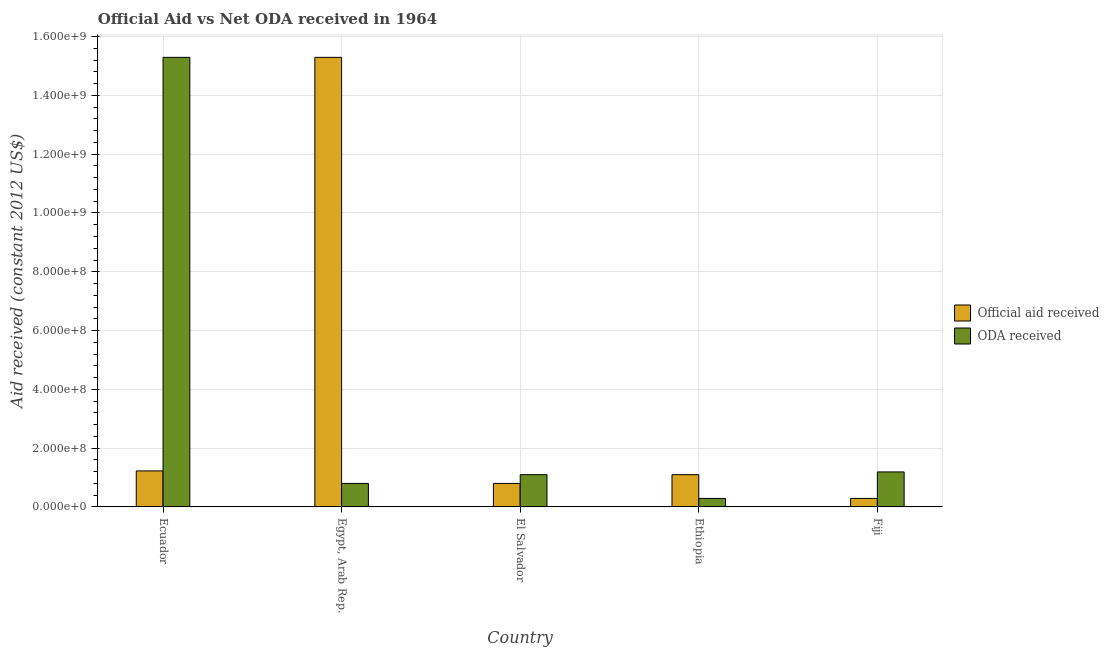How many different coloured bars are there?
Offer a terse response. 2. How many groups of bars are there?
Provide a short and direct response. 5. Are the number of bars per tick equal to the number of legend labels?
Your response must be concise. Yes. How many bars are there on the 5th tick from the right?
Provide a succinct answer. 2. What is the label of the 1st group of bars from the left?
Give a very brief answer. Ecuador. In how many cases, is the number of bars for a given country not equal to the number of legend labels?
Provide a succinct answer. 0. What is the oda received in Ethiopia?
Offer a very short reply. 2.89e+07. Across all countries, what is the maximum official aid received?
Your response must be concise. 1.53e+09. Across all countries, what is the minimum official aid received?
Provide a short and direct response. 2.89e+07. In which country was the oda received maximum?
Your answer should be very brief. Ecuador. In which country was the official aid received minimum?
Your response must be concise. Fiji. What is the total official aid received in the graph?
Provide a succinct answer. 1.87e+09. What is the difference between the official aid received in Ecuador and that in Egypt, Arab Rep.?
Offer a very short reply. -1.41e+09. What is the difference between the oda received in Ecuador and the official aid received in Ethiopia?
Your response must be concise. 1.42e+09. What is the average oda received per country?
Your response must be concise. 3.73e+08. What is the difference between the official aid received and oda received in El Salvador?
Give a very brief answer. -2.98e+07. What is the ratio of the official aid received in Egypt, Arab Rep. to that in Ethiopia?
Make the answer very short. 13.94. What is the difference between the highest and the second highest official aid received?
Make the answer very short. 1.41e+09. What is the difference between the highest and the lowest official aid received?
Your response must be concise. 1.50e+09. Is the sum of the official aid received in Ecuador and Ethiopia greater than the maximum oda received across all countries?
Provide a succinct answer. No. What does the 2nd bar from the left in Fiji represents?
Provide a succinct answer. ODA received. What does the 1st bar from the right in Ethiopia represents?
Your response must be concise. ODA received. How many bars are there?
Ensure brevity in your answer.  10. How many countries are there in the graph?
Keep it short and to the point. 5. What is the difference between two consecutive major ticks on the Y-axis?
Keep it short and to the point. 2.00e+08. Are the values on the major ticks of Y-axis written in scientific E-notation?
Keep it short and to the point. Yes. Where does the legend appear in the graph?
Offer a very short reply. Center right. How are the legend labels stacked?
Give a very brief answer. Vertical. What is the title of the graph?
Ensure brevity in your answer.  Official Aid vs Net ODA received in 1964 . Does "Excluding technical cooperation" appear as one of the legend labels in the graph?
Your response must be concise. No. What is the label or title of the Y-axis?
Offer a very short reply. Aid received (constant 2012 US$). What is the Aid received (constant 2012 US$) of Official aid received in Ecuador?
Make the answer very short. 1.23e+08. What is the Aid received (constant 2012 US$) in ODA received in Ecuador?
Give a very brief answer. 1.53e+09. What is the Aid received (constant 2012 US$) in Official aid received in Egypt, Arab Rep.?
Your answer should be compact. 1.53e+09. What is the Aid received (constant 2012 US$) in ODA received in Egypt, Arab Rep.?
Ensure brevity in your answer.  8.00e+07. What is the Aid received (constant 2012 US$) in Official aid received in El Salvador?
Your response must be concise. 8.00e+07. What is the Aid received (constant 2012 US$) of ODA received in El Salvador?
Ensure brevity in your answer.  1.10e+08. What is the Aid received (constant 2012 US$) in Official aid received in Ethiopia?
Offer a very short reply. 1.10e+08. What is the Aid received (constant 2012 US$) in ODA received in Ethiopia?
Your response must be concise. 2.89e+07. What is the Aid received (constant 2012 US$) in Official aid received in Fiji?
Give a very brief answer. 2.89e+07. What is the Aid received (constant 2012 US$) of ODA received in Fiji?
Your response must be concise. 1.19e+08. Across all countries, what is the maximum Aid received (constant 2012 US$) in Official aid received?
Your answer should be compact. 1.53e+09. Across all countries, what is the maximum Aid received (constant 2012 US$) in ODA received?
Provide a short and direct response. 1.53e+09. Across all countries, what is the minimum Aid received (constant 2012 US$) of Official aid received?
Offer a terse response. 2.89e+07. Across all countries, what is the minimum Aid received (constant 2012 US$) in ODA received?
Your response must be concise. 2.89e+07. What is the total Aid received (constant 2012 US$) in Official aid received in the graph?
Ensure brevity in your answer.  1.87e+09. What is the total Aid received (constant 2012 US$) in ODA received in the graph?
Make the answer very short. 1.87e+09. What is the difference between the Aid received (constant 2012 US$) of Official aid received in Ecuador and that in Egypt, Arab Rep.?
Keep it short and to the point. -1.41e+09. What is the difference between the Aid received (constant 2012 US$) in ODA received in Ecuador and that in Egypt, Arab Rep.?
Make the answer very short. 1.45e+09. What is the difference between the Aid received (constant 2012 US$) in Official aid received in Ecuador and that in El Salvador?
Keep it short and to the point. 4.26e+07. What is the difference between the Aid received (constant 2012 US$) in ODA received in Ecuador and that in El Salvador?
Offer a very short reply. 1.42e+09. What is the difference between the Aid received (constant 2012 US$) of Official aid received in Ecuador and that in Ethiopia?
Give a very brief answer. 1.29e+07. What is the difference between the Aid received (constant 2012 US$) of ODA received in Ecuador and that in Ethiopia?
Give a very brief answer. 1.50e+09. What is the difference between the Aid received (constant 2012 US$) in Official aid received in Ecuador and that in Fiji?
Provide a succinct answer. 9.37e+07. What is the difference between the Aid received (constant 2012 US$) in ODA received in Ecuador and that in Fiji?
Make the answer very short. 1.41e+09. What is the difference between the Aid received (constant 2012 US$) in Official aid received in Egypt, Arab Rep. and that in El Salvador?
Provide a short and direct response. 1.45e+09. What is the difference between the Aid received (constant 2012 US$) of ODA received in Egypt, Arab Rep. and that in El Salvador?
Give a very brief answer. -2.98e+07. What is the difference between the Aid received (constant 2012 US$) in Official aid received in Egypt, Arab Rep. and that in Ethiopia?
Your response must be concise. 1.42e+09. What is the difference between the Aid received (constant 2012 US$) of ODA received in Egypt, Arab Rep. and that in Ethiopia?
Make the answer very short. 5.11e+07. What is the difference between the Aid received (constant 2012 US$) in Official aid received in Egypt, Arab Rep. and that in Fiji?
Ensure brevity in your answer.  1.50e+09. What is the difference between the Aid received (constant 2012 US$) in ODA received in Egypt, Arab Rep. and that in Fiji?
Make the answer very short. -3.91e+07. What is the difference between the Aid received (constant 2012 US$) in Official aid received in El Salvador and that in Ethiopia?
Your response must be concise. -2.98e+07. What is the difference between the Aid received (constant 2012 US$) in ODA received in El Salvador and that in Ethiopia?
Ensure brevity in your answer.  8.08e+07. What is the difference between the Aid received (constant 2012 US$) of Official aid received in El Salvador and that in Fiji?
Keep it short and to the point. 5.11e+07. What is the difference between the Aid received (constant 2012 US$) of ODA received in El Salvador and that in Fiji?
Your answer should be compact. -9.34e+06. What is the difference between the Aid received (constant 2012 US$) in Official aid received in Ethiopia and that in Fiji?
Ensure brevity in your answer.  8.08e+07. What is the difference between the Aid received (constant 2012 US$) of ODA received in Ethiopia and that in Fiji?
Give a very brief answer. -9.02e+07. What is the difference between the Aid received (constant 2012 US$) in Official aid received in Ecuador and the Aid received (constant 2012 US$) in ODA received in Egypt, Arab Rep.?
Offer a terse response. 4.26e+07. What is the difference between the Aid received (constant 2012 US$) of Official aid received in Ecuador and the Aid received (constant 2012 US$) of ODA received in El Salvador?
Keep it short and to the point. 1.29e+07. What is the difference between the Aid received (constant 2012 US$) in Official aid received in Ecuador and the Aid received (constant 2012 US$) in ODA received in Ethiopia?
Ensure brevity in your answer.  9.37e+07. What is the difference between the Aid received (constant 2012 US$) of Official aid received in Ecuador and the Aid received (constant 2012 US$) of ODA received in Fiji?
Make the answer very short. 3.52e+06. What is the difference between the Aid received (constant 2012 US$) of Official aid received in Egypt, Arab Rep. and the Aid received (constant 2012 US$) of ODA received in El Salvador?
Ensure brevity in your answer.  1.42e+09. What is the difference between the Aid received (constant 2012 US$) in Official aid received in Egypt, Arab Rep. and the Aid received (constant 2012 US$) in ODA received in Ethiopia?
Ensure brevity in your answer.  1.50e+09. What is the difference between the Aid received (constant 2012 US$) in Official aid received in Egypt, Arab Rep. and the Aid received (constant 2012 US$) in ODA received in Fiji?
Provide a succinct answer. 1.41e+09. What is the difference between the Aid received (constant 2012 US$) in Official aid received in El Salvador and the Aid received (constant 2012 US$) in ODA received in Ethiopia?
Your response must be concise. 5.11e+07. What is the difference between the Aid received (constant 2012 US$) in Official aid received in El Salvador and the Aid received (constant 2012 US$) in ODA received in Fiji?
Give a very brief answer. -3.91e+07. What is the difference between the Aid received (constant 2012 US$) of Official aid received in Ethiopia and the Aid received (constant 2012 US$) of ODA received in Fiji?
Provide a succinct answer. -9.34e+06. What is the average Aid received (constant 2012 US$) in Official aid received per country?
Offer a terse response. 3.74e+08. What is the average Aid received (constant 2012 US$) of ODA received per country?
Offer a very short reply. 3.73e+08. What is the difference between the Aid received (constant 2012 US$) in Official aid received and Aid received (constant 2012 US$) in ODA received in Ecuador?
Give a very brief answer. -1.41e+09. What is the difference between the Aid received (constant 2012 US$) in Official aid received and Aid received (constant 2012 US$) in ODA received in Egypt, Arab Rep.?
Offer a terse response. 1.45e+09. What is the difference between the Aid received (constant 2012 US$) of Official aid received and Aid received (constant 2012 US$) of ODA received in El Salvador?
Your answer should be compact. -2.98e+07. What is the difference between the Aid received (constant 2012 US$) of Official aid received and Aid received (constant 2012 US$) of ODA received in Ethiopia?
Your answer should be very brief. 8.08e+07. What is the difference between the Aid received (constant 2012 US$) in Official aid received and Aid received (constant 2012 US$) in ODA received in Fiji?
Keep it short and to the point. -9.02e+07. What is the ratio of the Aid received (constant 2012 US$) of Official aid received in Ecuador to that in Egypt, Arab Rep.?
Keep it short and to the point. 0.08. What is the ratio of the Aid received (constant 2012 US$) of ODA received in Ecuador to that in Egypt, Arab Rep.?
Provide a short and direct response. 19.13. What is the ratio of the Aid received (constant 2012 US$) of Official aid received in Ecuador to that in El Salvador?
Provide a short and direct response. 1.53. What is the ratio of the Aid received (constant 2012 US$) of ODA received in Ecuador to that in El Salvador?
Keep it short and to the point. 13.94. What is the ratio of the Aid received (constant 2012 US$) of Official aid received in Ecuador to that in Ethiopia?
Offer a terse response. 1.12. What is the ratio of the Aid received (constant 2012 US$) in ODA received in Ecuador to that in Ethiopia?
Your answer should be compact. 52.94. What is the ratio of the Aid received (constant 2012 US$) of Official aid received in Ecuador to that in Fiji?
Keep it short and to the point. 4.24. What is the ratio of the Aid received (constant 2012 US$) in ODA received in Ecuador to that in Fiji?
Make the answer very short. 12.85. What is the ratio of the Aid received (constant 2012 US$) of Official aid received in Egypt, Arab Rep. to that in El Salvador?
Your answer should be compact. 19.13. What is the ratio of the Aid received (constant 2012 US$) of ODA received in Egypt, Arab Rep. to that in El Salvador?
Provide a short and direct response. 0.73. What is the ratio of the Aid received (constant 2012 US$) of Official aid received in Egypt, Arab Rep. to that in Ethiopia?
Provide a succinct answer. 13.94. What is the ratio of the Aid received (constant 2012 US$) of ODA received in Egypt, Arab Rep. to that in Ethiopia?
Your answer should be compact. 2.77. What is the ratio of the Aid received (constant 2012 US$) of Official aid received in Egypt, Arab Rep. to that in Fiji?
Provide a short and direct response. 52.94. What is the ratio of the Aid received (constant 2012 US$) of ODA received in Egypt, Arab Rep. to that in Fiji?
Provide a succinct answer. 0.67. What is the ratio of the Aid received (constant 2012 US$) in Official aid received in El Salvador to that in Ethiopia?
Make the answer very short. 0.73. What is the ratio of the Aid received (constant 2012 US$) in ODA received in El Salvador to that in Ethiopia?
Provide a succinct answer. 3.8. What is the ratio of the Aid received (constant 2012 US$) of Official aid received in El Salvador to that in Fiji?
Make the answer very short. 2.77. What is the ratio of the Aid received (constant 2012 US$) in ODA received in El Salvador to that in Fiji?
Offer a terse response. 0.92. What is the ratio of the Aid received (constant 2012 US$) in Official aid received in Ethiopia to that in Fiji?
Offer a very short reply. 3.8. What is the ratio of the Aid received (constant 2012 US$) in ODA received in Ethiopia to that in Fiji?
Ensure brevity in your answer.  0.24. What is the difference between the highest and the second highest Aid received (constant 2012 US$) of Official aid received?
Keep it short and to the point. 1.41e+09. What is the difference between the highest and the second highest Aid received (constant 2012 US$) in ODA received?
Give a very brief answer. 1.41e+09. What is the difference between the highest and the lowest Aid received (constant 2012 US$) in Official aid received?
Provide a short and direct response. 1.50e+09. What is the difference between the highest and the lowest Aid received (constant 2012 US$) of ODA received?
Offer a terse response. 1.50e+09. 